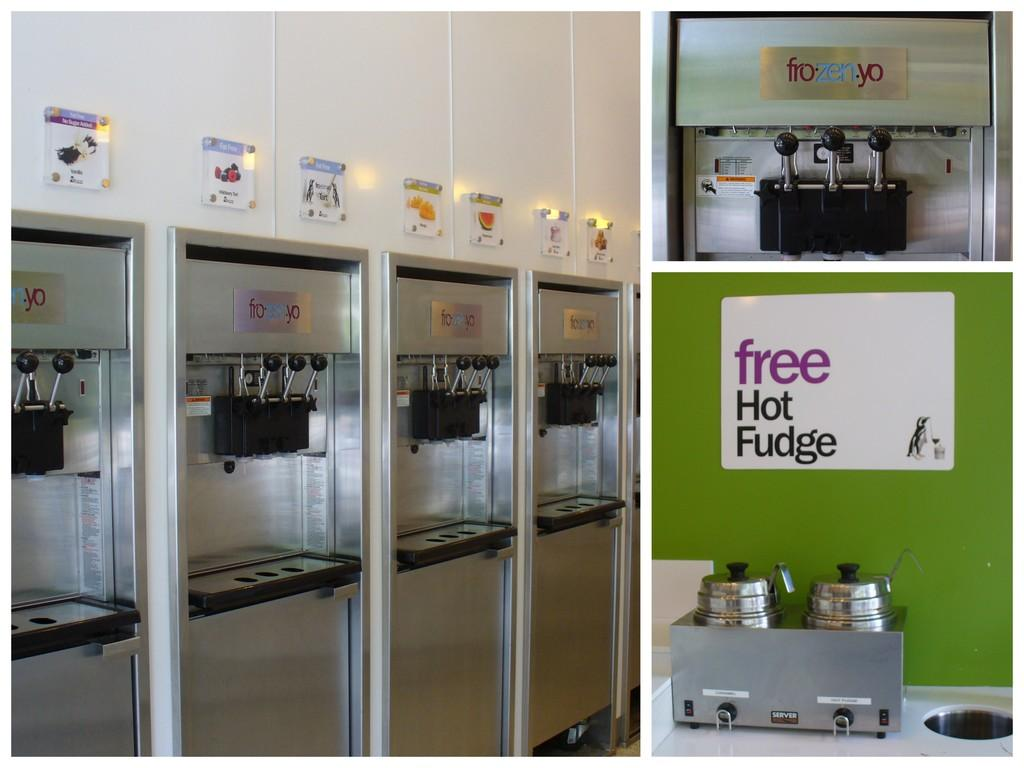What type of machines are present in the image? There are many ice-cream machines and two hitting machines in the image. What else can be seen in the image besides the machines? There is a board and tags in the image. What type of wrench is being used to fix the ice-cream machine in the image? There is no wrench present in the image. How much shade is provided by the ice-cream machines in the image? There is no mention of shade in the image, as it focuses on the machines and other objects. 